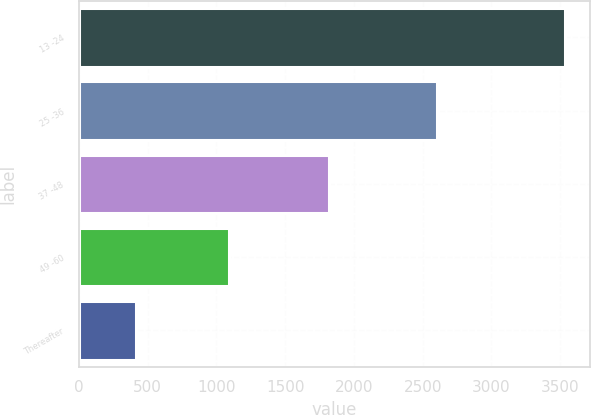<chart> <loc_0><loc_0><loc_500><loc_500><bar_chart><fcel>13 -24<fcel>25 -36<fcel>37 -48<fcel>49 -60<fcel>Thereafter<nl><fcel>3538<fcel>2606<fcel>1821<fcel>1092<fcel>412<nl></chart> 